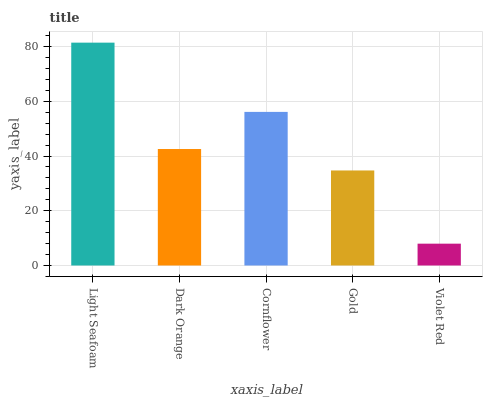Is Dark Orange the minimum?
Answer yes or no. No. Is Dark Orange the maximum?
Answer yes or no. No. Is Light Seafoam greater than Dark Orange?
Answer yes or no. Yes. Is Dark Orange less than Light Seafoam?
Answer yes or no. Yes. Is Dark Orange greater than Light Seafoam?
Answer yes or no. No. Is Light Seafoam less than Dark Orange?
Answer yes or no. No. Is Dark Orange the high median?
Answer yes or no. Yes. Is Dark Orange the low median?
Answer yes or no. Yes. Is Gold the high median?
Answer yes or no. No. Is Cornflower the low median?
Answer yes or no. No. 